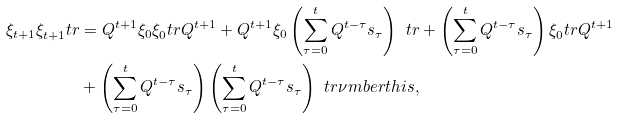Convert formula to latex. <formula><loc_0><loc_0><loc_500><loc_500>\xi _ { t + 1 } \xi _ { t + 1 } ^ { \ } t r & = Q ^ { t + 1 } \xi _ { 0 } \xi _ { 0 } ^ { \ } t r Q ^ { t + 1 } + Q ^ { t + 1 } \xi _ { 0 } \left ( \sum _ { \tau = 0 } ^ { t } Q ^ { t - \tau } s _ { \tau } \right ) ^ { \ } t r + \left ( \sum _ { \tau = 0 } ^ { t } Q ^ { t - \tau } s _ { \tau } \right ) \xi _ { 0 } ^ { \ } t r Q ^ { t + 1 } \\ & + \left ( \sum _ { \tau = 0 } ^ { t } Q ^ { t - \tau } s _ { \tau } \right ) \left ( \sum _ { \tau = 0 } ^ { t } Q ^ { t - \tau } s _ { \tau } \right ) ^ { \ } t r \nu m b e r t h i s ,</formula> 